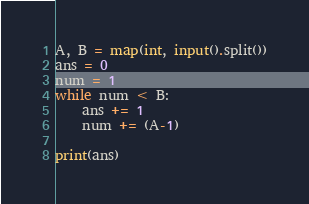Convert code to text. <code><loc_0><loc_0><loc_500><loc_500><_Python_>A, B = map(int, input().split())
ans = 0
num = 1
while num < B:
    ans += 1
    num += (A-1)

print(ans)</code> 